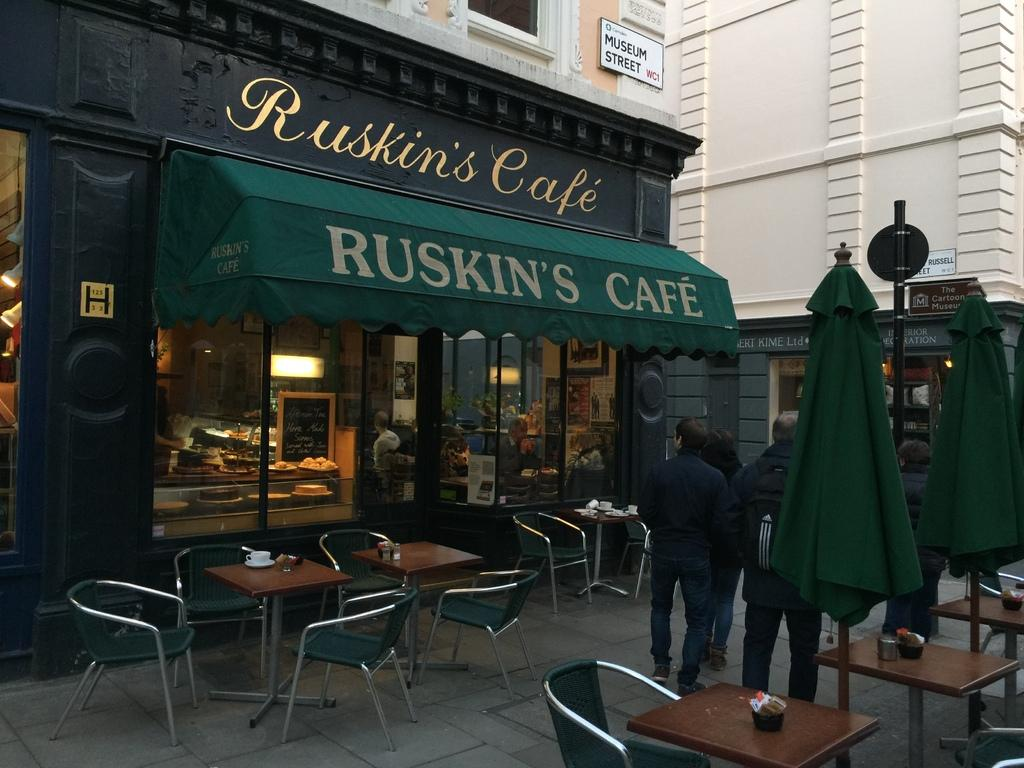What is happening in the image? There are people standing in the image. What type of establishment can be seen in the image? There is a cafe in the image. What is the name of the cafe? The cafe is named "Ruskin's Cafe." What type of form can be seen flying in a flock in the image? There is no form or flock present in the image; it features people standing in front of a cafe. 